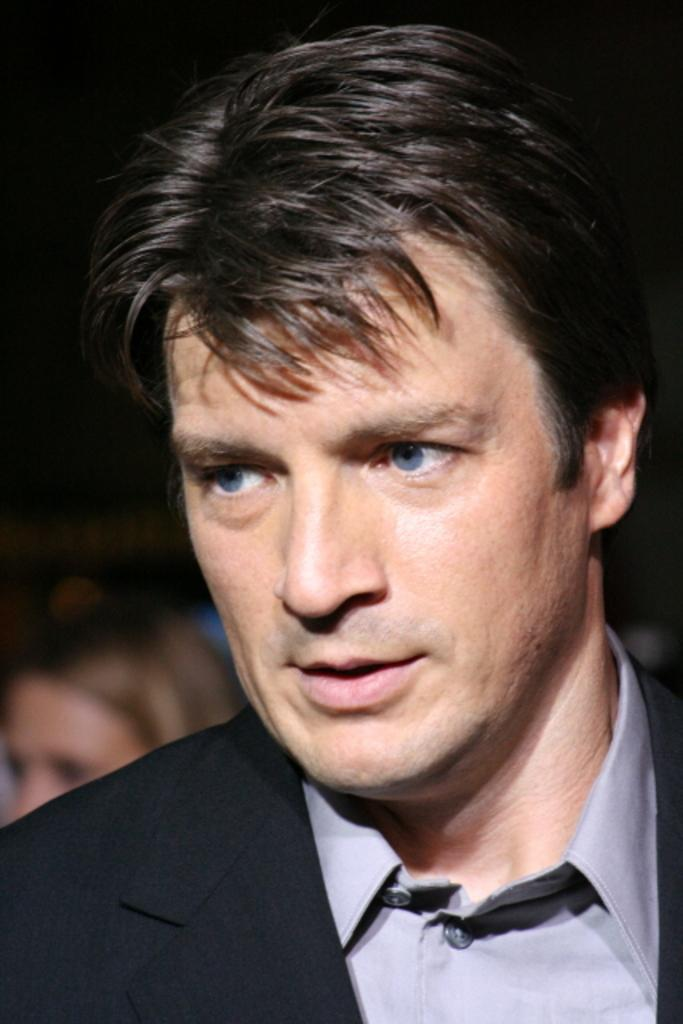What is the main subject in the foreground of the image? There is a person in the foreground of the image. Can you describe the person in the background of the image? There is another person in the background of the image. What is the color or lighting condition of the background in the image? The background of the image is dark. What type of tin can be seen in the image? There is no tin present in the image. What is the cause of the darkness in the background of the image? The provided facts do not specify the cause of the darkness in the background of the image. 